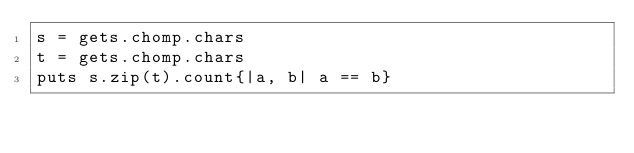Convert code to text. <code><loc_0><loc_0><loc_500><loc_500><_Ruby_>s = gets.chomp.chars
t = gets.chomp.chars
puts s.zip(t).count{|a, b| a == b}</code> 